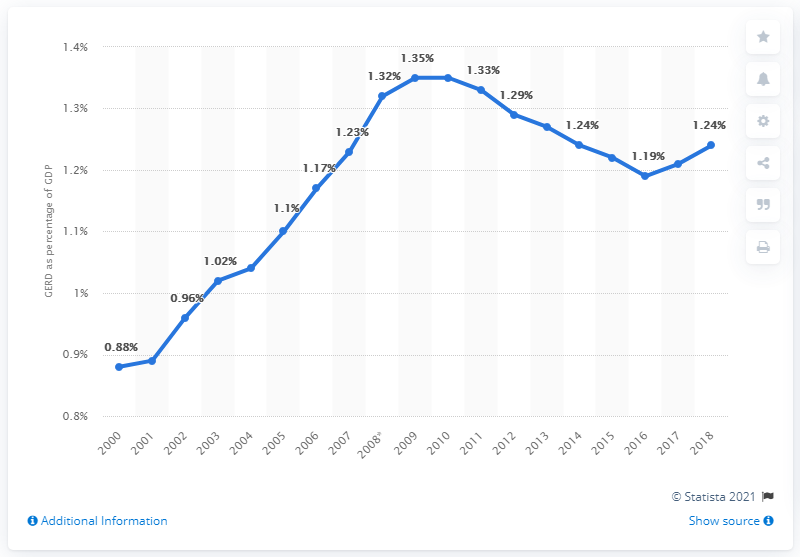Outline some significant characteristics in this image. In 2015, the share of GERD in Spain's GDP was 1.21%. 